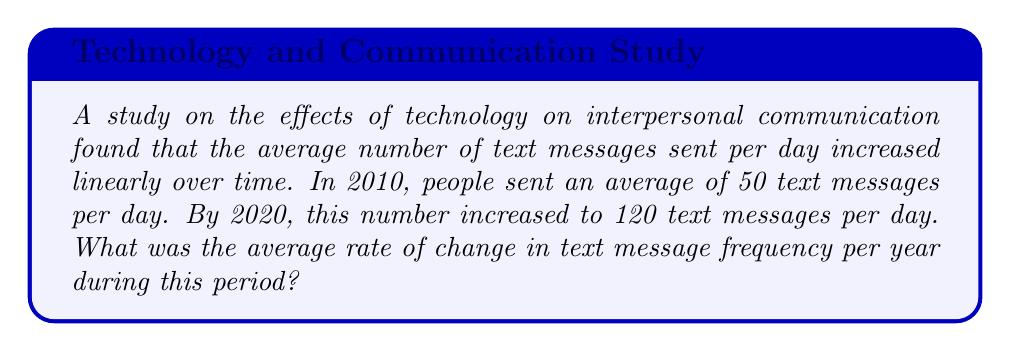Can you answer this question? To solve this problem, we need to calculate the rate of change in text message frequency over time. Let's break it down step-by-step:

1. Identify the given information:
   - Initial year: 2010
   - Initial text messages per day: 50
   - Final year: 2020
   - Final text messages per day: 120

2. Calculate the total change in text messages per day:
   $\Delta \text{messages} = 120 - 50 = 70$ messages

3. Calculate the time period:
   $\Delta \text{time} = 2020 - 2010 = 10$ years

4. Use the rate of change formula:
   $$\text{Rate of change} = \frac{\text{Change in y}}{\text{Change in x}} = \frac{\Delta \text{messages}}{\Delta \text{time}}$$

5. Substitute the values:
   $$\text{Rate of change} = \frac{70 \text{ messages}}{10 \text{ years}} = 7 \text{ messages/year}$$

Therefore, the average rate of change in text message frequency was 7 messages per year during this period.
Answer: 7 messages/year 